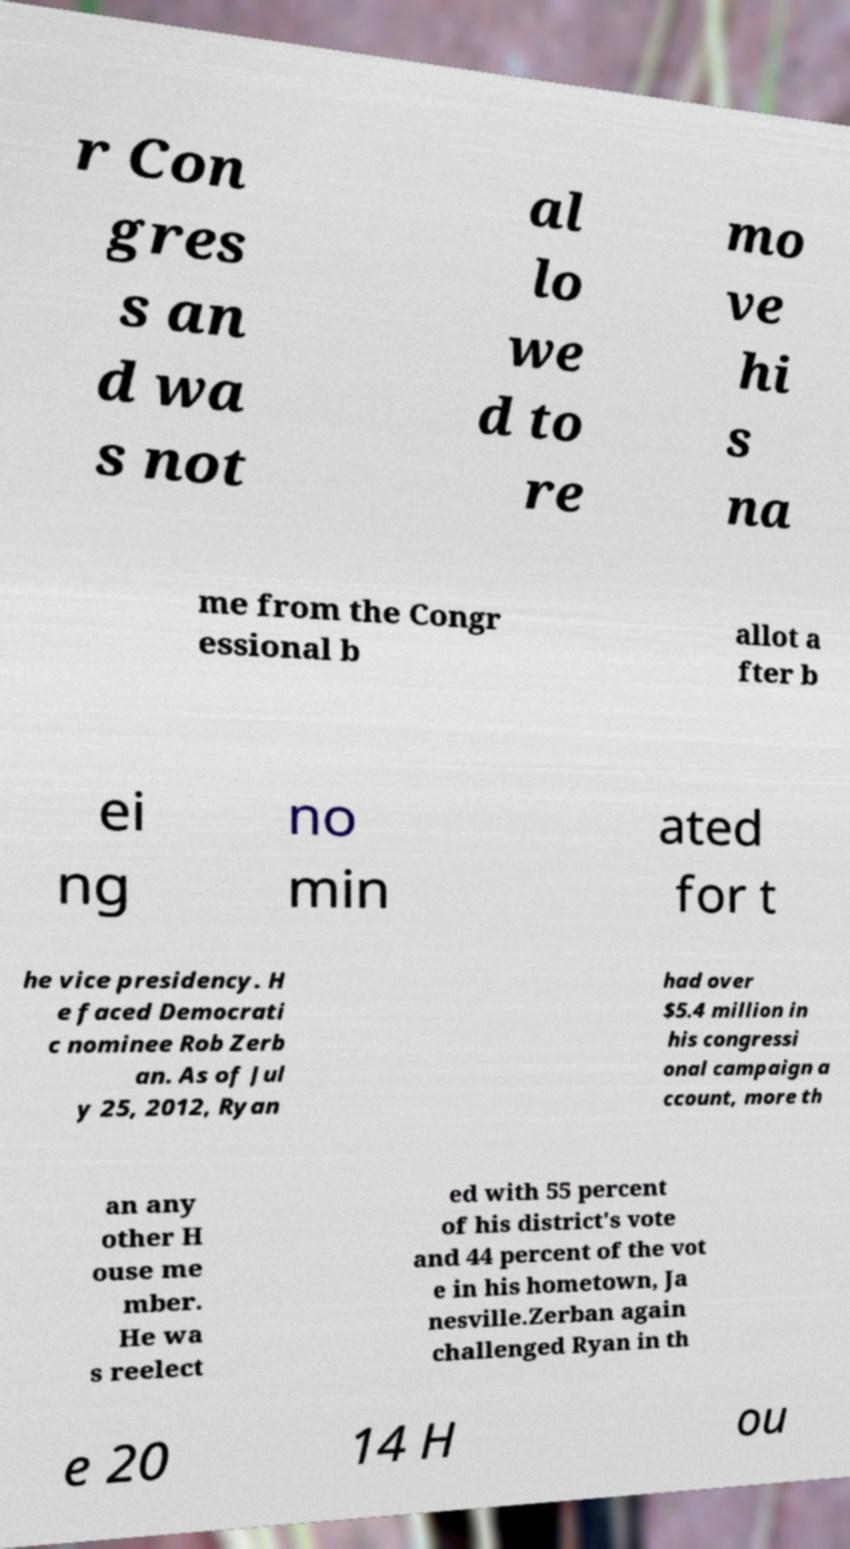What messages or text are displayed in this image? I need them in a readable, typed format. r Con gres s an d wa s not al lo we d to re mo ve hi s na me from the Congr essional b allot a fter b ei ng no min ated for t he vice presidency. H e faced Democrati c nominee Rob Zerb an. As of Jul y 25, 2012, Ryan had over $5.4 million in his congressi onal campaign a ccount, more th an any other H ouse me mber. He wa s reelect ed with 55 percent of his district's vote and 44 percent of the vot e in his hometown, Ja nesville.Zerban again challenged Ryan in th e 20 14 H ou 